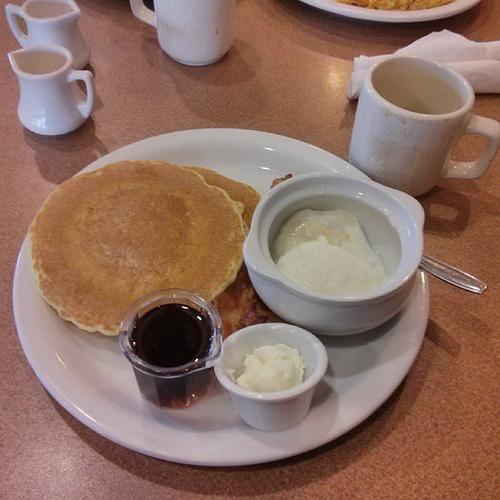How many plates are there?
Give a very brief answer. 1. 